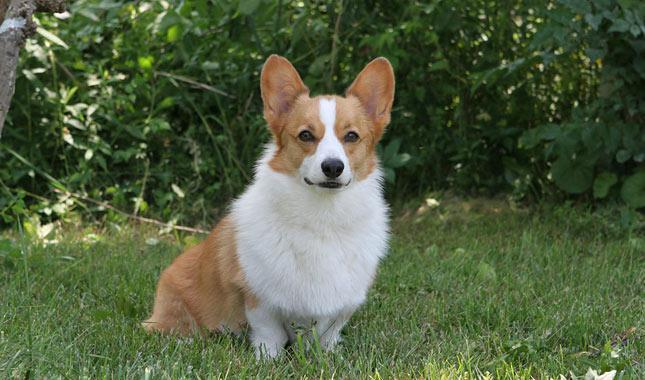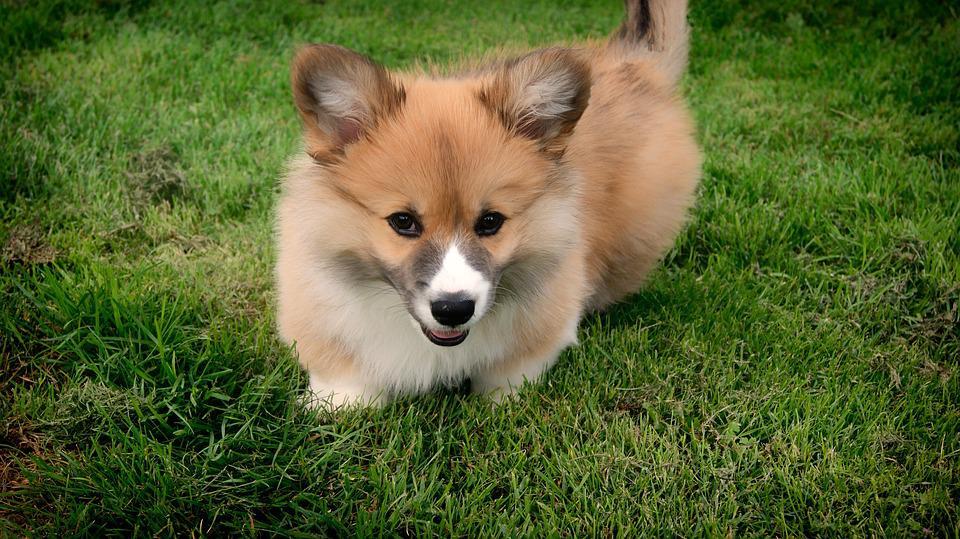The first image is the image on the left, the second image is the image on the right. Examine the images to the left and right. Is the description "At least one dog is sitting." accurate? Answer yes or no. Yes. The first image is the image on the left, the second image is the image on the right. Evaluate the accuracy of this statement regarding the images: "A dog is stationary with their tongue hanging out.". Is it true? Answer yes or no. No. 